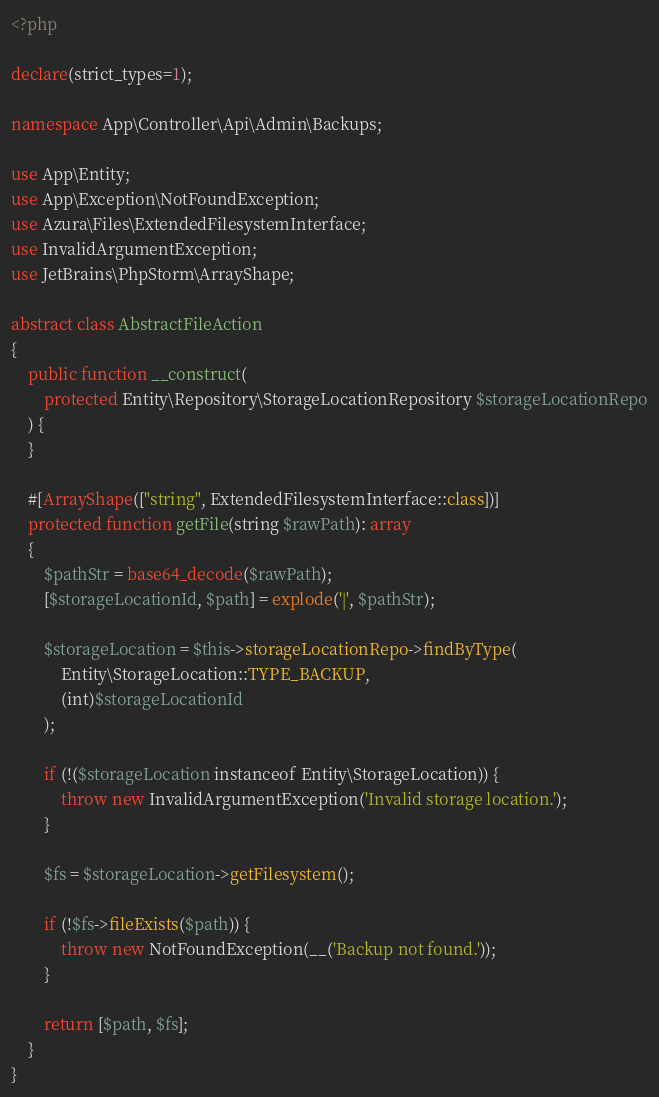Convert code to text. <code><loc_0><loc_0><loc_500><loc_500><_PHP_><?php

declare(strict_types=1);

namespace App\Controller\Api\Admin\Backups;

use App\Entity;
use App\Exception\NotFoundException;
use Azura\Files\ExtendedFilesystemInterface;
use InvalidArgumentException;
use JetBrains\PhpStorm\ArrayShape;

abstract class AbstractFileAction
{
    public function __construct(
        protected Entity\Repository\StorageLocationRepository $storageLocationRepo
    ) {
    }

    #[ArrayShape(["string", ExtendedFilesystemInterface::class])]
    protected function getFile(string $rawPath): array
    {
        $pathStr = base64_decode($rawPath);
        [$storageLocationId, $path] = explode('|', $pathStr);

        $storageLocation = $this->storageLocationRepo->findByType(
            Entity\StorageLocation::TYPE_BACKUP,
            (int)$storageLocationId
        );

        if (!($storageLocation instanceof Entity\StorageLocation)) {
            throw new InvalidArgumentException('Invalid storage location.');
        }

        $fs = $storageLocation->getFilesystem();

        if (!$fs->fileExists($path)) {
            throw new NotFoundException(__('Backup not found.'));
        }

        return [$path, $fs];
    }
}
</code> 